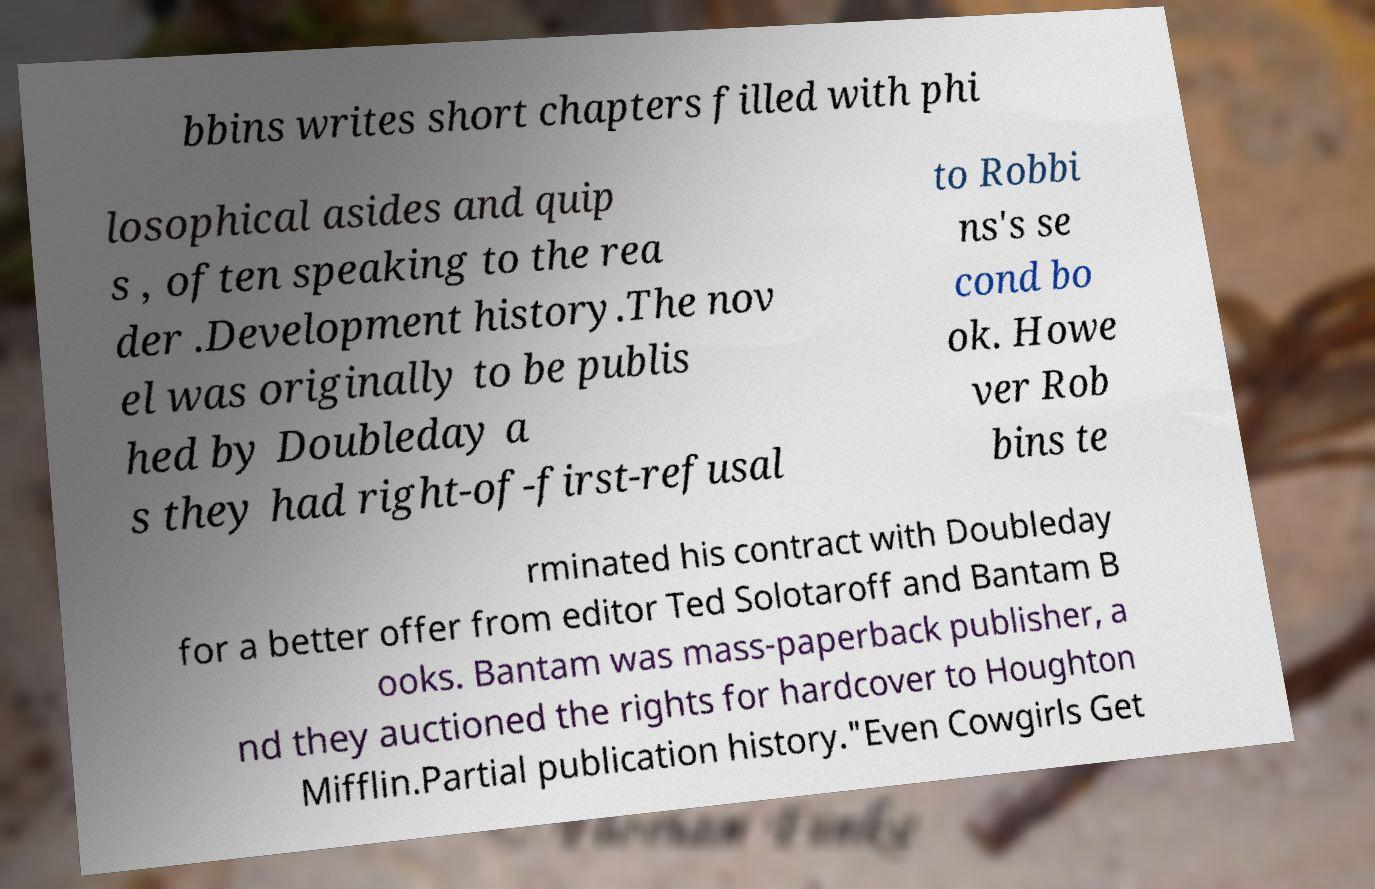For documentation purposes, I need the text within this image transcribed. Could you provide that? bbins writes short chapters filled with phi losophical asides and quip s , often speaking to the rea der .Development history.The nov el was originally to be publis hed by Doubleday a s they had right-of-first-refusal to Robbi ns's se cond bo ok. Howe ver Rob bins te rminated his contract with Doubleday for a better offer from editor Ted Solotaroff and Bantam B ooks. Bantam was mass-paperback publisher, a nd they auctioned the rights for hardcover to Houghton Mifflin.Partial publication history."Even Cowgirls Get 